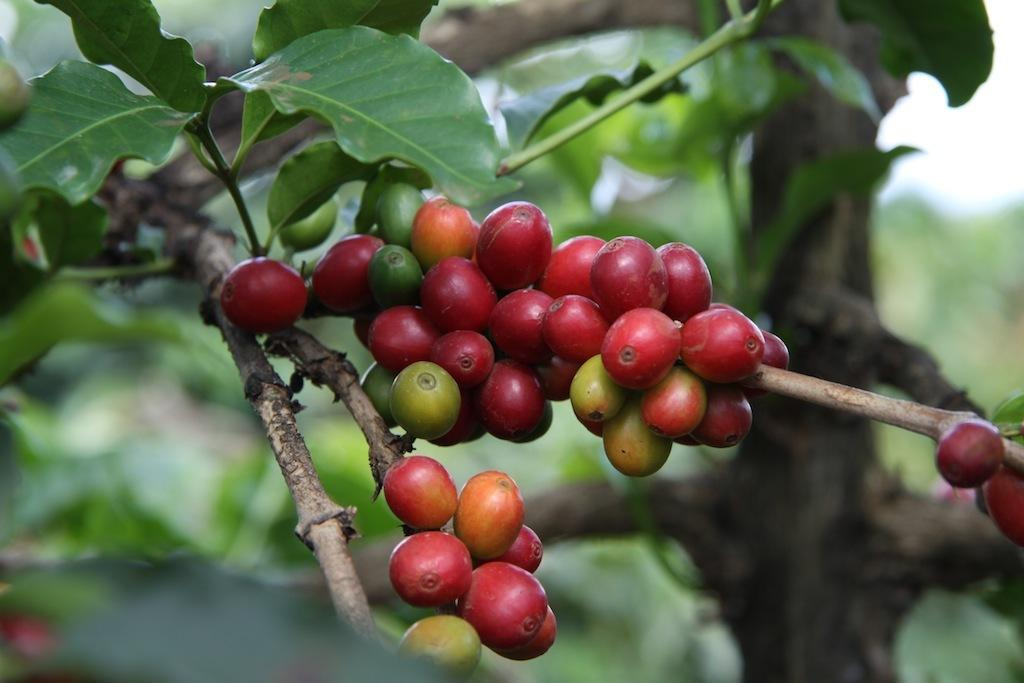What type of fruit can be seen on the tree in the image? There are red cherries on the tree in the image. Can you describe the background of the image? The background is green and blurred. What type of pies can be seen in the image? There are no pies present in the image; it features a tree with red cherries and a green blurred background. 